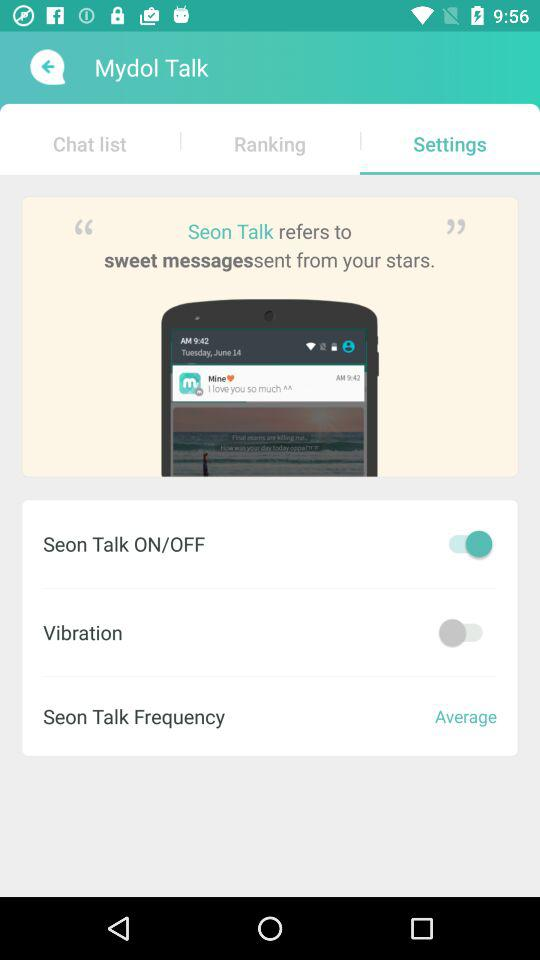What is the status of Seon Talk Frequency? The status is average. 